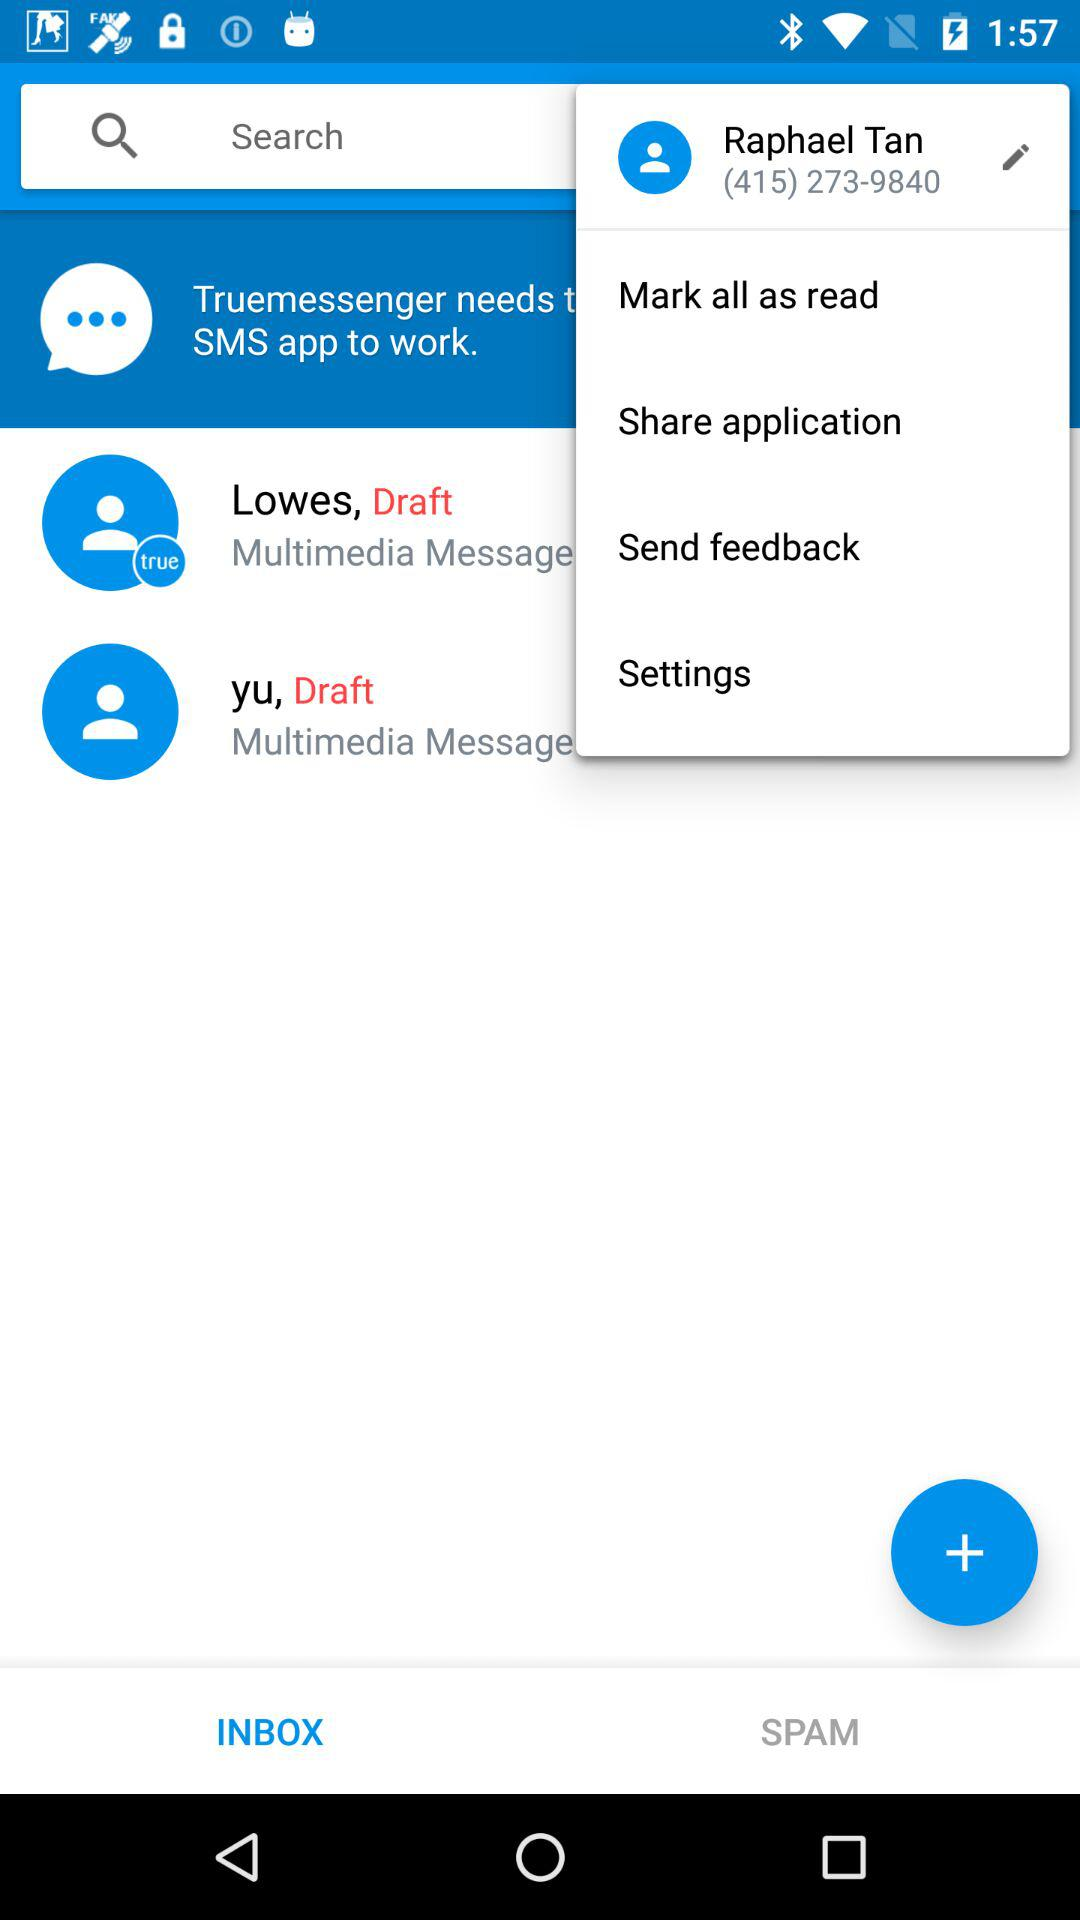What is the contact number? The contact number is (415) 273-9840. 